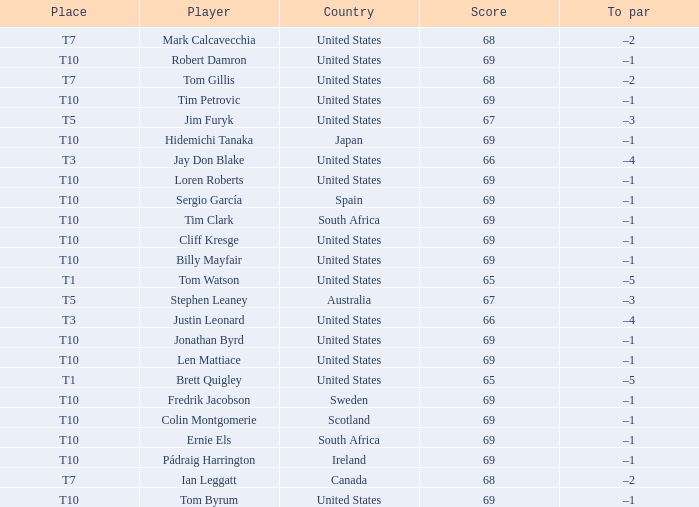Help me parse the entirety of this table. {'header': ['Place', 'Player', 'Country', 'Score', 'To par'], 'rows': [['T7', 'Mark Calcavecchia', 'United States', '68', '–2'], ['T10', 'Robert Damron', 'United States', '69', '–1'], ['T7', 'Tom Gillis', 'United States', '68', '–2'], ['T10', 'Tim Petrovic', 'United States', '69', '–1'], ['T5', 'Jim Furyk', 'United States', '67', '–3'], ['T10', 'Hidemichi Tanaka', 'Japan', '69', '–1'], ['T3', 'Jay Don Blake', 'United States', '66', '–4'], ['T10', 'Loren Roberts', 'United States', '69', '–1'], ['T10', 'Sergio García', 'Spain', '69', '–1'], ['T10', 'Tim Clark', 'South Africa', '69', '–1'], ['T10', 'Cliff Kresge', 'United States', '69', '–1'], ['T10', 'Billy Mayfair', 'United States', '69', '–1'], ['T1', 'Tom Watson', 'United States', '65', '–5'], ['T5', 'Stephen Leaney', 'Australia', '67', '–3'], ['T3', 'Justin Leonard', 'United States', '66', '–4'], ['T10', 'Jonathan Byrd', 'United States', '69', '–1'], ['T10', 'Len Mattiace', 'United States', '69', '–1'], ['T1', 'Brett Quigley', 'United States', '65', '–5'], ['T10', 'Fredrik Jacobson', 'Sweden', '69', '–1'], ['T10', 'Colin Montgomerie', 'Scotland', '69', '–1'], ['T10', 'Ernie Els', 'South Africa', '69', '–1'], ['T10', 'Pádraig Harrington', 'Ireland', '69', '–1'], ['T7', 'Ian Leggatt', 'Canada', '68', '–2'], ['T10', 'Tom Byrum', 'United States', '69', '–1']]} Which country has is Len Mattiace in T10 place? United States. 